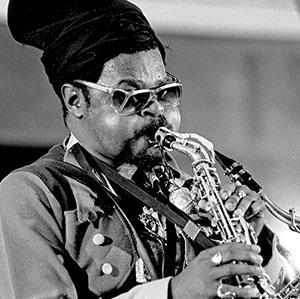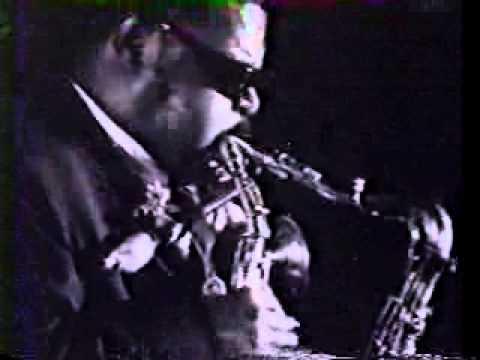The first image is the image on the left, the second image is the image on the right. Evaluate the accuracy of this statement regarding the images: "An image shows a sax player wearing a tall black hat and glasses.". Is it true? Answer yes or no. Yes. The first image is the image on the left, the second image is the image on the right. Analyze the images presented: Is the assertion "There are three or more people clearly visible." valid? Answer yes or no. No. 